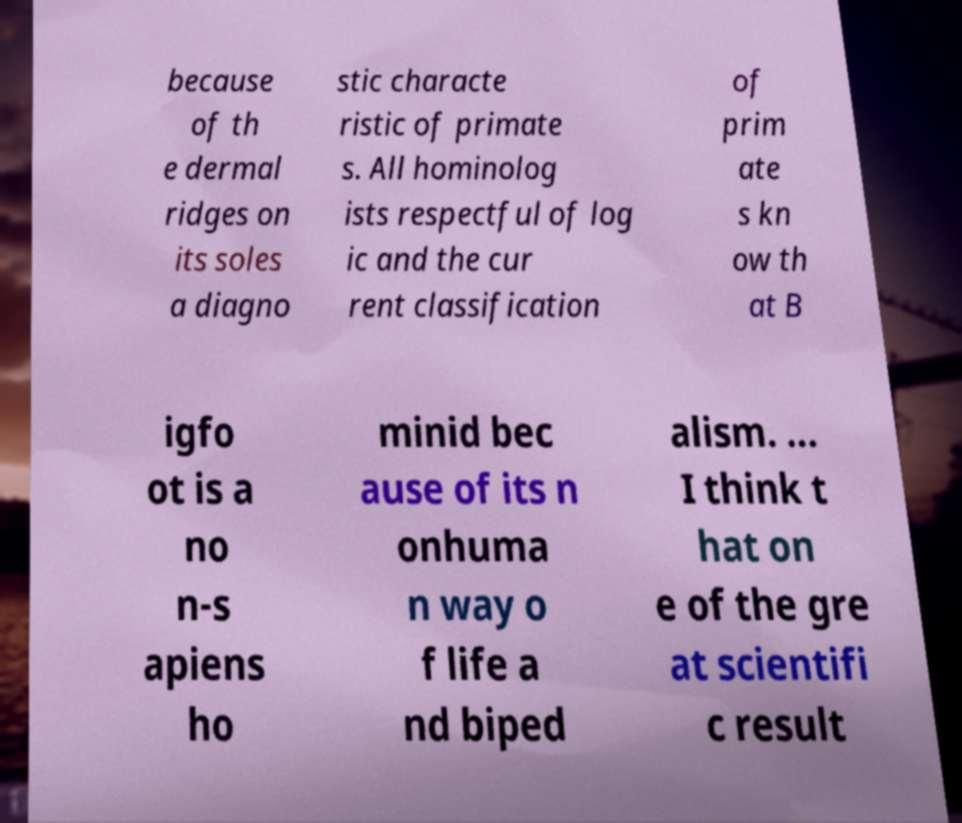Please identify and transcribe the text found in this image. because of th e dermal ridges on its soles a diagno stic characte ristic of primate s. All hominolog ists respectful of log ic and the cur rent classification of prim ate s kn ow th at B igfo ot is a no n-s apiens ho minid bec ause of its n onhuma n way o f life a nd biped alism. ... I think t hat on e of the gre at scientifi c result 